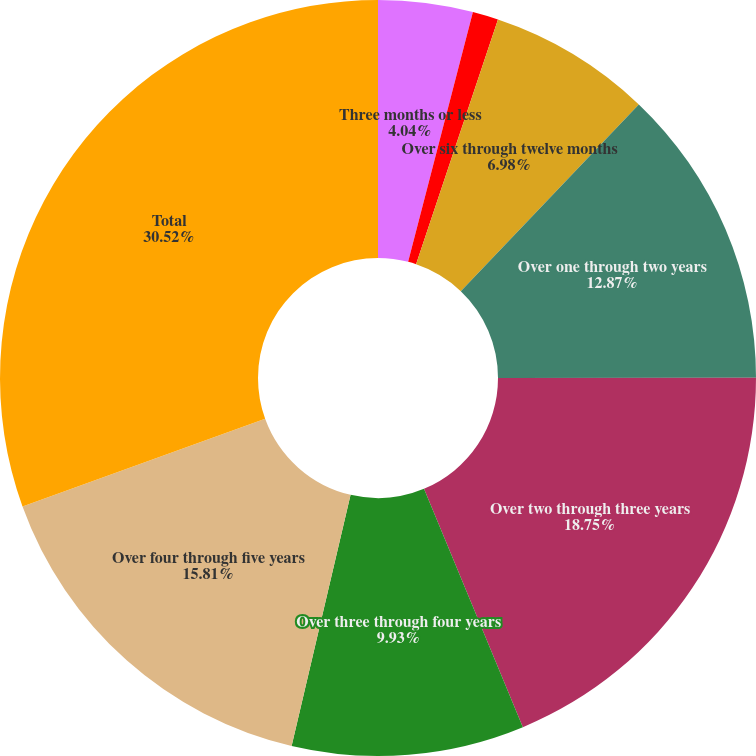<chart> <loc_0><loc_0><loc_500><loc_500><pie_chart><fcel>Three months or less<fcel>Over three through six months<fcel>Over six through twelve months<fcel>Over one through two years<fcel>Over two through three years<fcel>Over three through four years<fcel>Over four through five years<fcel>Total<nl><fcel>4.04%<fcel>1.1%<fcel>6.98%<fcel>12.87%<fcel>18.75%<fcel>9.93%<fcel>15.81%<fcel>30.52%<nl></chart> 